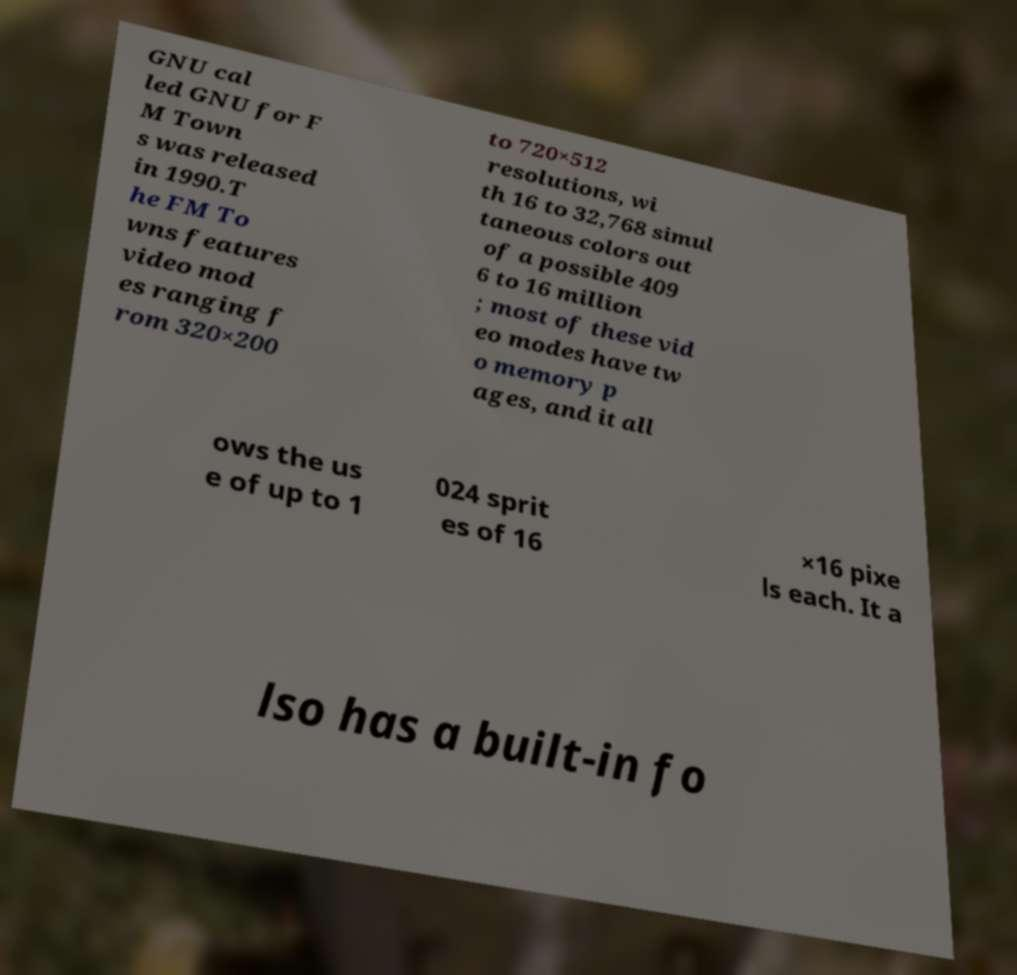What messages or text are displayed in this image? I need them in a readable, typed format. GNU cal led GNU for F M Town s was released in 1990.T he FM To wns features video mod es ranging f rom 320×200 to 720×512 resolutions, wi th 16 to 32,768 simul taneous colors out of a possible 409 6 to 16 million ; most of these vid eo modes have tw o memory p ages, and it all ows the us e of up to 1 024 sprit es of 16 ×16 pixe ls each. It a lso has a built-in fo 